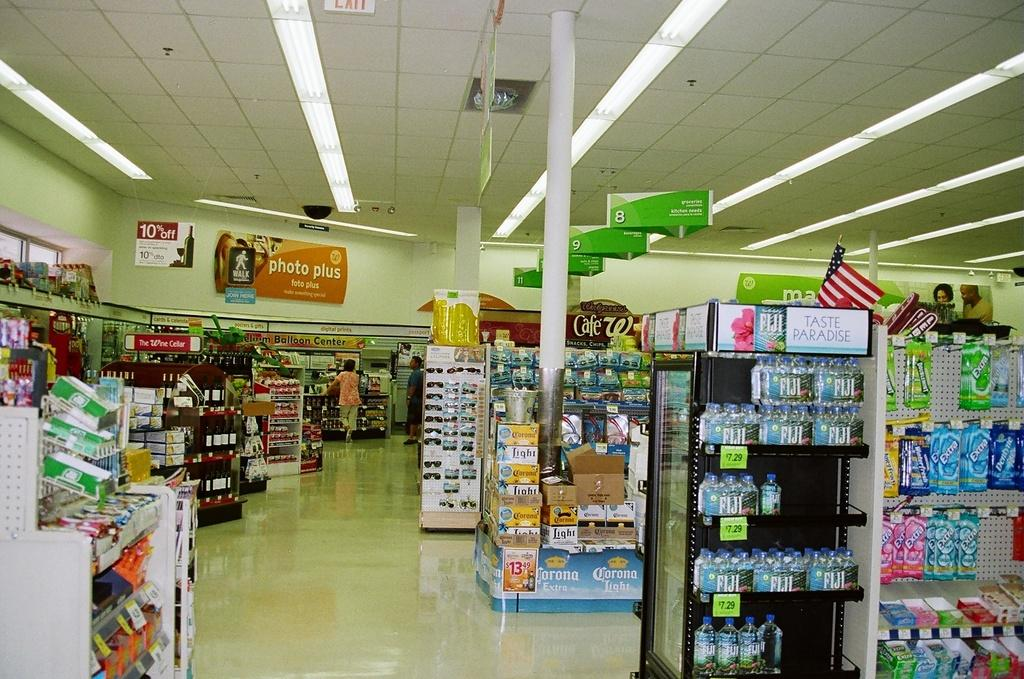<image>
Create a compact narrative representing the image presented. A few customers are visible by the photo area of a drugstore. 